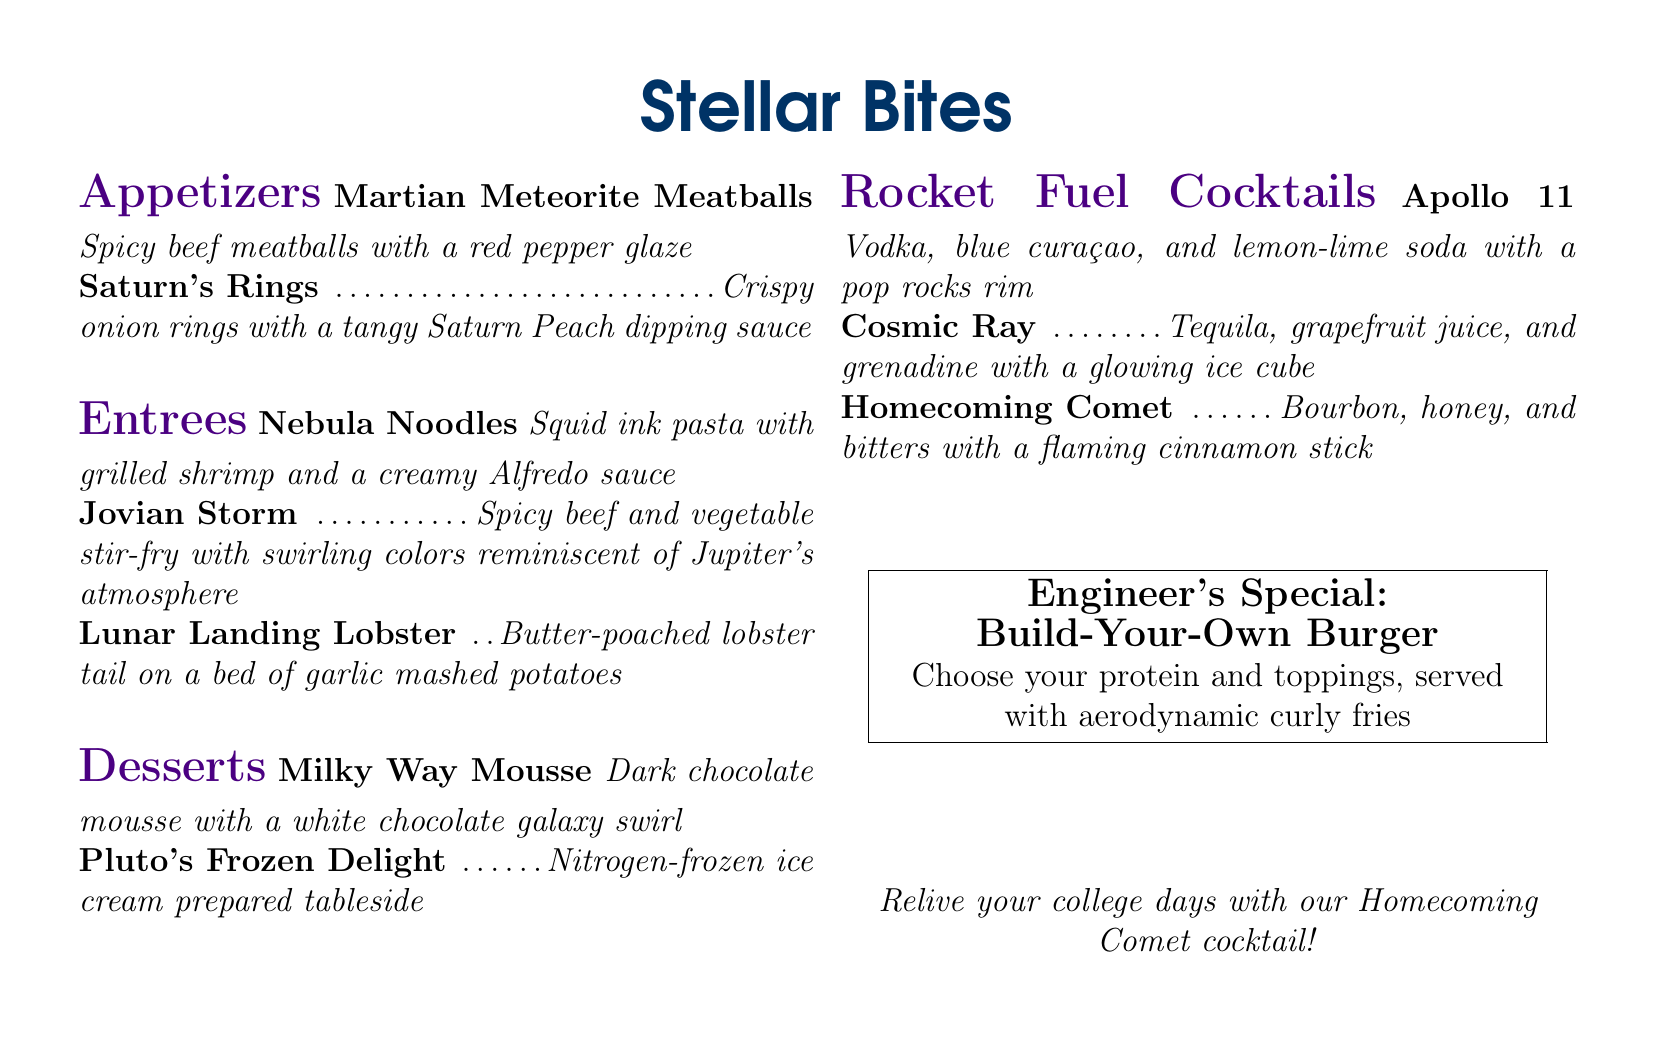What are the two appetizers listed on the menu? The two appetizers are Martian Meteorite Meatballs and Saturn's Rings.
Answer: Martian Meteorite Meatballs, Saturn's Rings What special dish allows customization by choosing protein and toppings? The dish is called the Engineer's Special: Build-Your-Own Burger.
Answer: Build-Your-Own Burger Which cocktail features a glowing ice cube? Cosmic Ray is the cocktail that includes a glowing ice cube.
Answer: Cosmic Ray What dessert is prepared tableside? The dessert that is prepared tableside is Pluto's Frozen Delight.
Answer: Pluto's Frozen Delight How many entrees are listed on the menu? There are three entrees listed on the menu: Nebula Noodles, Jovian Storm, and Lunar Landing Lobster.
Answer: Three What type of sauce accompanies Saturn's Rings? The sauce is a tangy Saturn Peach dipping sauce.
Answer: Saturn Peach dipping sauce What is the main ingredient in the Milky Way Mousse? The main ingredient in the Milky Way Mousse is dark chocolate.
Answer: Dark chocolate Which cocktail is named after a historic moon landing mission? The cocktail named after a historic moon landing mission is Apollo 11.
Answer: Apollo 11 What is the protein base for the Lunar Landing Lobster entree? The protein base is butter-poached lobster tail.
Answer: Butter-poached lobster tail 